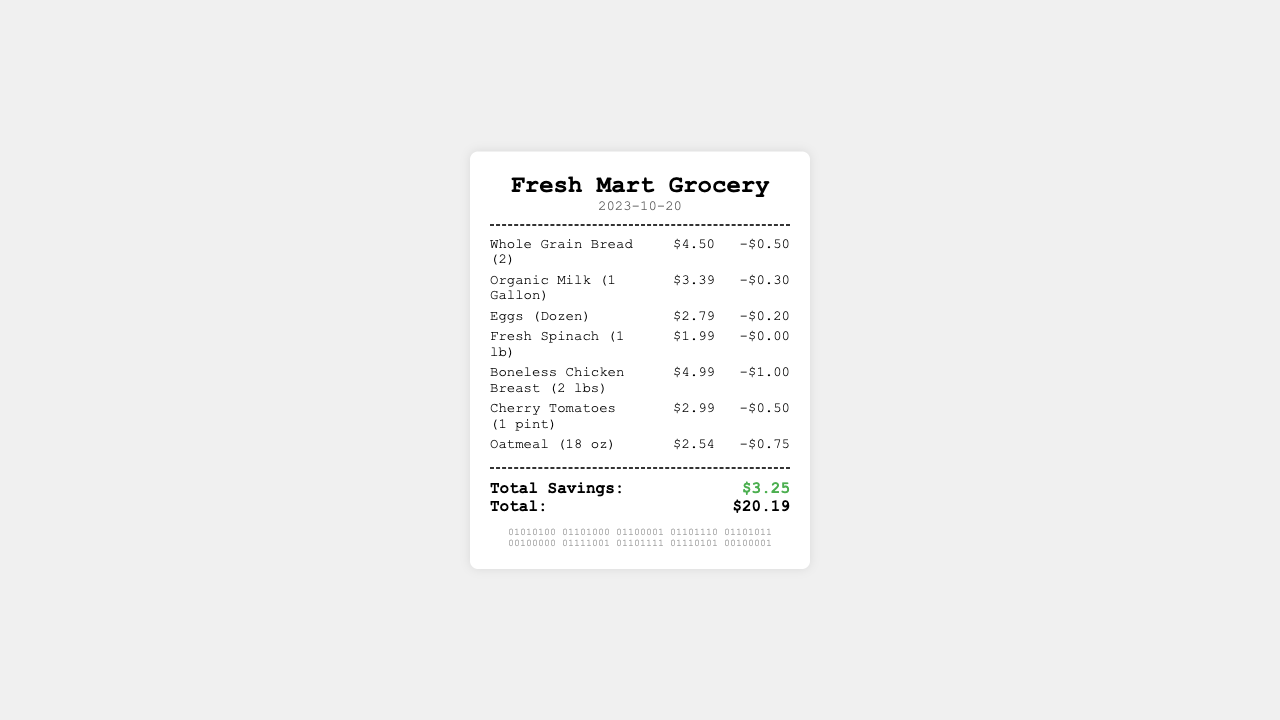What is the date of the receipt? The date is explicitly stated at the top of the receipt under the date section.
Answer: 2023-10-20 What is the total savings from discounts? The total savings is highlighted at the bottom of the receipt under the totals section.
Answer: $3.25 How much did the Organic Milk cost? The cost is listed next to the item name in the items section of the receipt.
Answer: $3.39 What is the price of the Whole Grain Bread? The price is specified in the items section and is presented alongside the item name.
Answer: $4.50 How many items have discounts applied? The discounts are shown next to each item in the items section, indicating how many items received discounts.
Answer: 6 What is the total amount spent on groceries? The total amount is indicated in the totals section of the receipt.
Answer: $20.19 Which item had the highest discount? By analyzing the discounts listed for each item, the item with the highest discount can be determined.
Answer: Oatmeal How many pounds of Boneless Chicken Breast were purchased? The quantity is noted in parentheses next to the item name in the itemized list.
Answer: 2 lbs What is the store name on the receipt? The store name is clearly stated at the top of the receipt in bold format.
Answer: Fresh Mart Grocery 